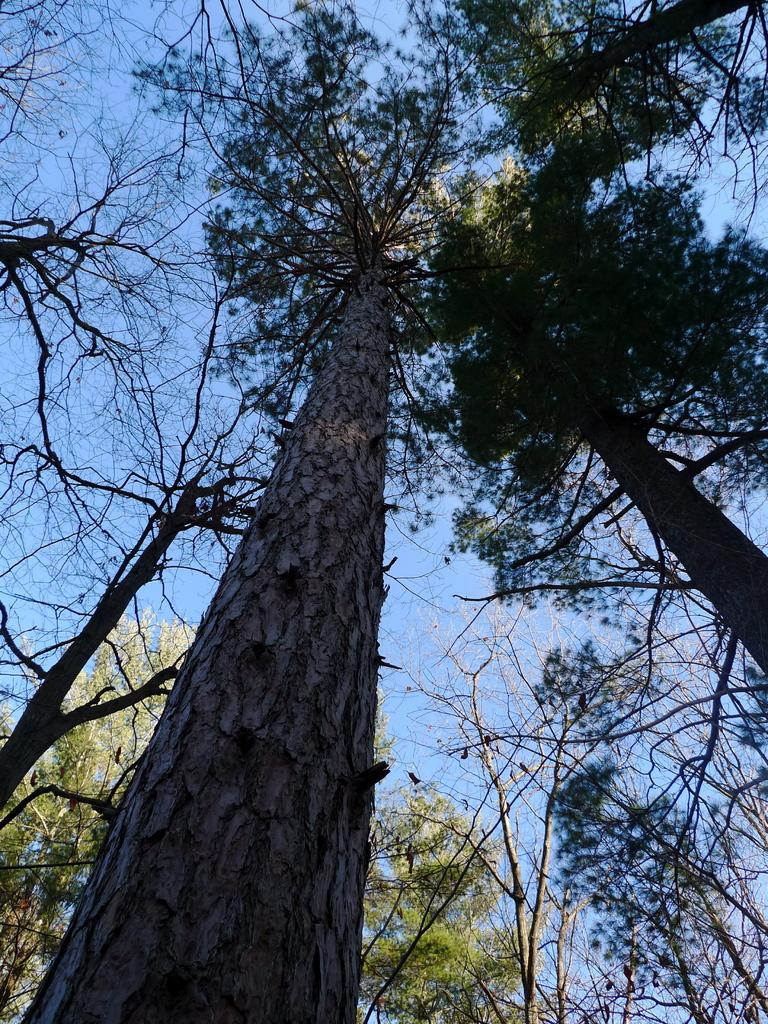What type of vegetation can be seen in the image? There are trees in the image. What is visible in the background of the image? The sky is visible in the background of the image. How many fingers can be seen pointing at the trees in the image? There are no fingers visible in the image, as it only features trees and the sky. 